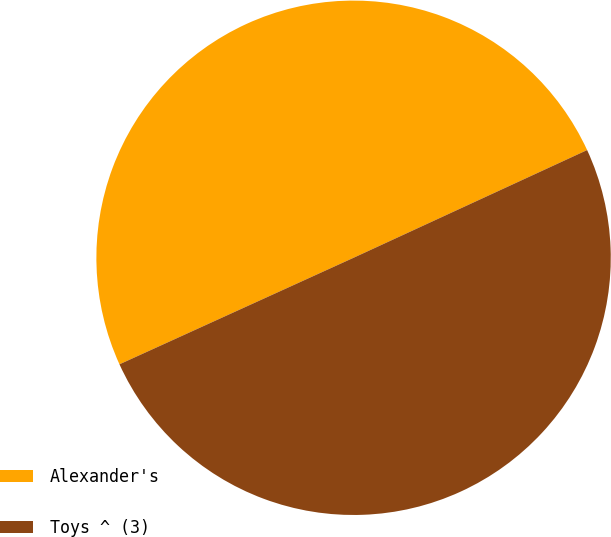Convert chart. <chart><loc_0><loc_0><loc_500><loc_500><pie_chart><fcel>Alexander's<fcel>Toys ^ (3)<nl><fcel>49.92%<fcel>50.08%<nl></chart> 